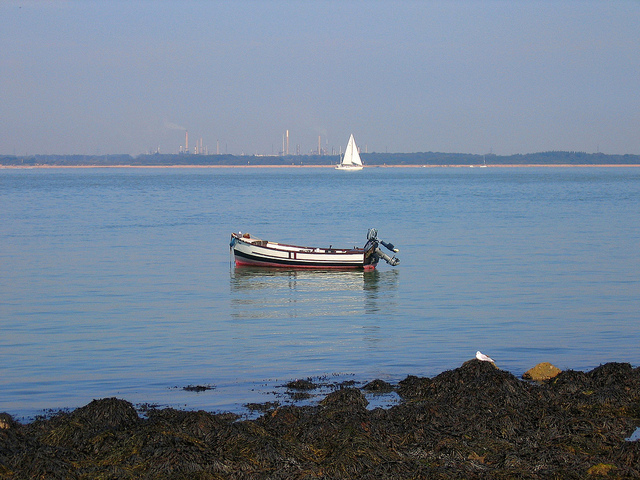How many cars are to the left of the bus? Upon observing the image, it appears that there is no bus present; therefore, there are zero cars positioned to the left of a bus. In the serene seascape, we can see a small boat calmly floating near the shore and another sailboat in the distance, with no vehicles in sight. 